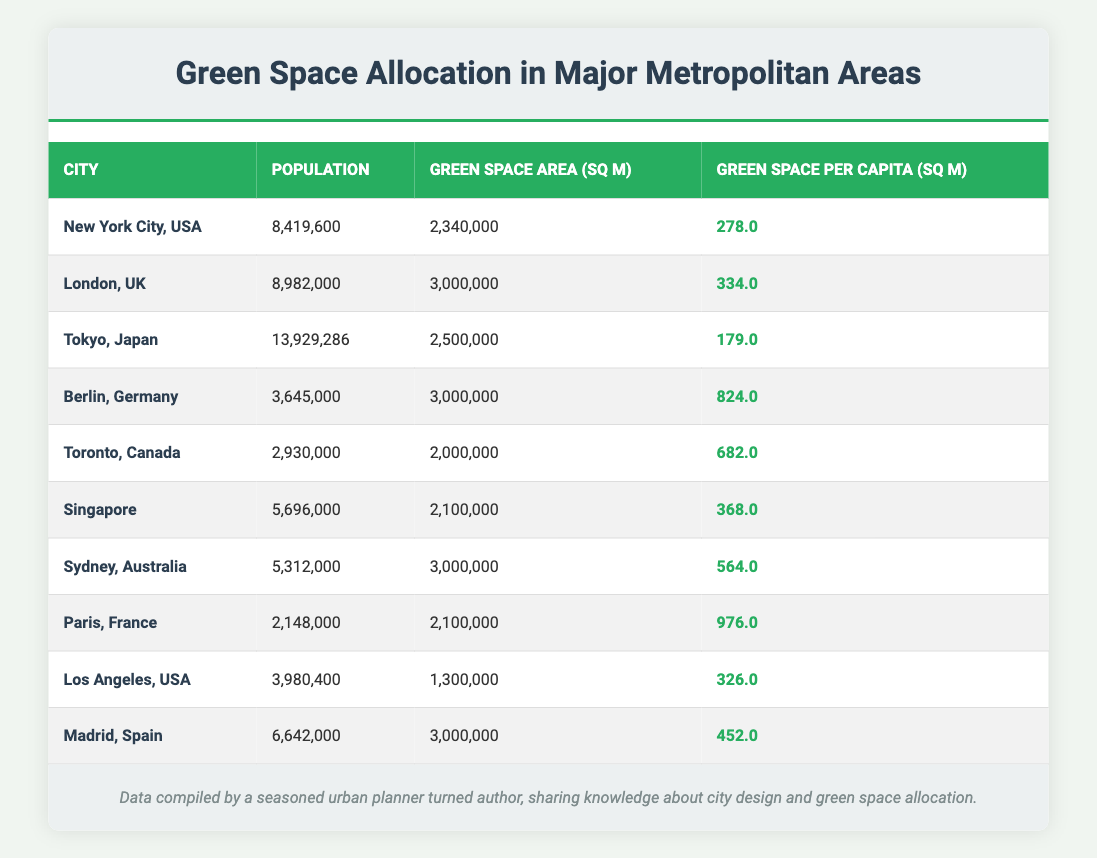What is the green space allocation per capita for New York City? According to the table, New York City has a green space allocation per capita of 278.0 square meters. This is directly extracted from the corresponding row in the table.
Answer: 278.0 Which city has the highest green space allocation per capita? The table indicates that Paris, France has the highest green space allocation per capita of 976.0 square meters, which is the largest value in the "Green Space per Capita" column.
Answer: 976.0 How many more square meters of green space per capita does Berlin have compared to Tokyo? Berlin has 824.0 square meters, while Tokyo has 179.0 square meters. The difference is calculated as 824.0 - 179.0 = 645.0 square meters.
Answer: 645.0 Is the total green space area for Los Angeles greater than that of Tokyo? Los Angeles has a green space area of 1,300,000 square meters, while Tokyo has 2,500,000 square meters. Since 1,300,000 is less than 2,500,000, the statement is false.
Answer: No What is the average green space allocation per capita for all cities listed in the table? To calculate the average: sum up all the per capita values: (278.0 + 334.0 + 179.0 + 824.0 + 682.0 + 368.0 + 564.0 + 976.0 + 326.0 + 452.0) = 4,382.0. Then, divide by the number of cities (10), yielding an average of 4,382.0 / 10 = 438.2 square meters per capita.
Answer: 438.2 Which city has the lowest population among the listed metropolitan areas? The table shows that Paris, France has the lowest population at 2,148,000, which can be identified by comparing the "Population" column across all rows.
Answer: 2,148,000 